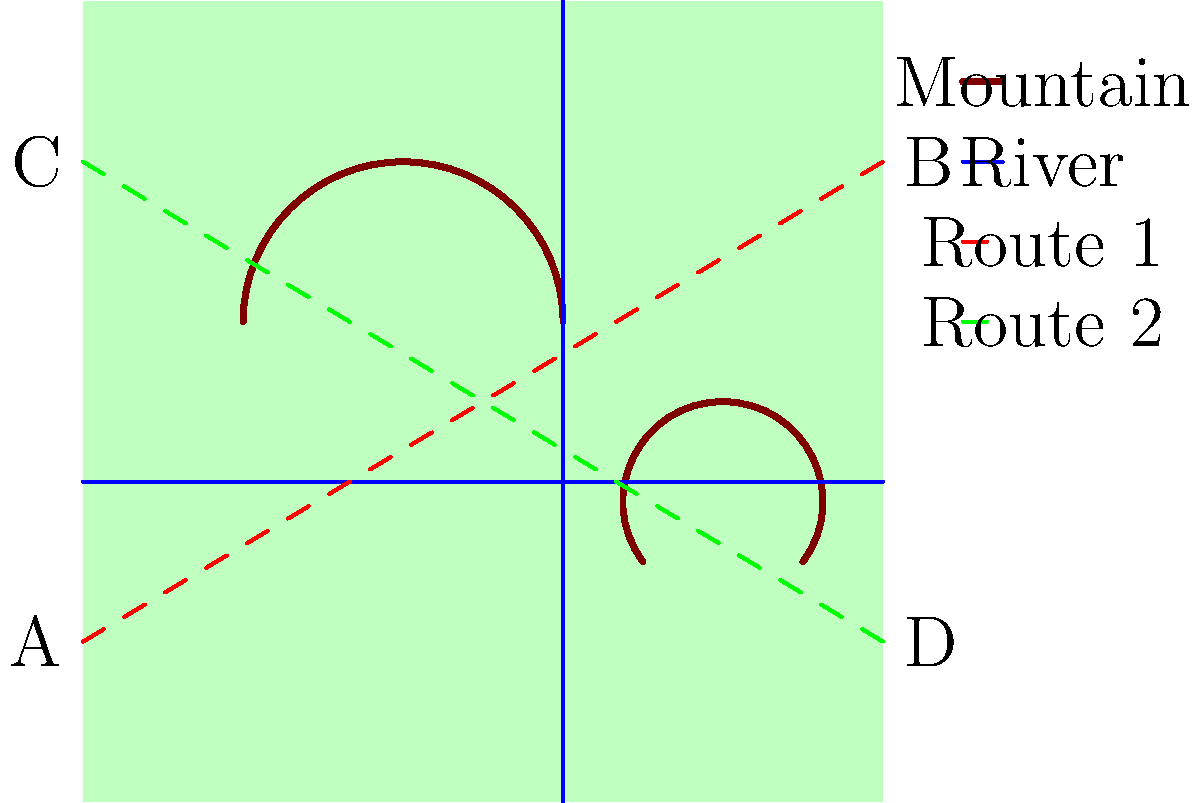As a general planning a ground offensive, you need to establish the most efficient supply route from point A to point B or from point C to point D. Given the terrain map above, which route would you choose for your supply convoys and why? To determine the most efficient supply route, we need to consider several factors:

1. Distance: Both routes appear to have similar lengths.

2. Terrain obstacles:
   - Route 1 (A to B, red dashed line):
     a. Crosses one river
     b. Passes through two mountain ranges
   - Route 2 (C to D, green dashed line):
     a. Crosses two rivers
     b. Avoids all mountain ranges

3. Military considerations:
   a. River crossings are vulnerable points that may require additional engineering support and slow down convoys.
   b. Mountain passages can be treacherous, requiring specialized vehicles and potentially slowing down the convoy.
   c. Flat terrain allows for faster movement and is easier to defend.

4. Efficiency analysis:
   - Route 1 has fewer river crossings but encounters more difficult terrain (mountains).
   - Route 2 has more river crossings but avoids all mountains, offering more consistent flat terrain.

5. Ground forces perspective:
   As a general who prioritizes ground forces, the ability to move quickly and maintain consistent supply lines is crucial. Route 2 offers:
   a. More predictable travel times due to consistent terrain
   b. Easier navigation for large convoys
   c. Better opportunities for defensive positions along the route
   d. Simpler logistics for maintaining the supply line

Therefore, despite having one additional river crossing, Route 2 (C to D) is the more efficient choice for ground-based supply convoys.
Answer: Route 2 (C to D) 